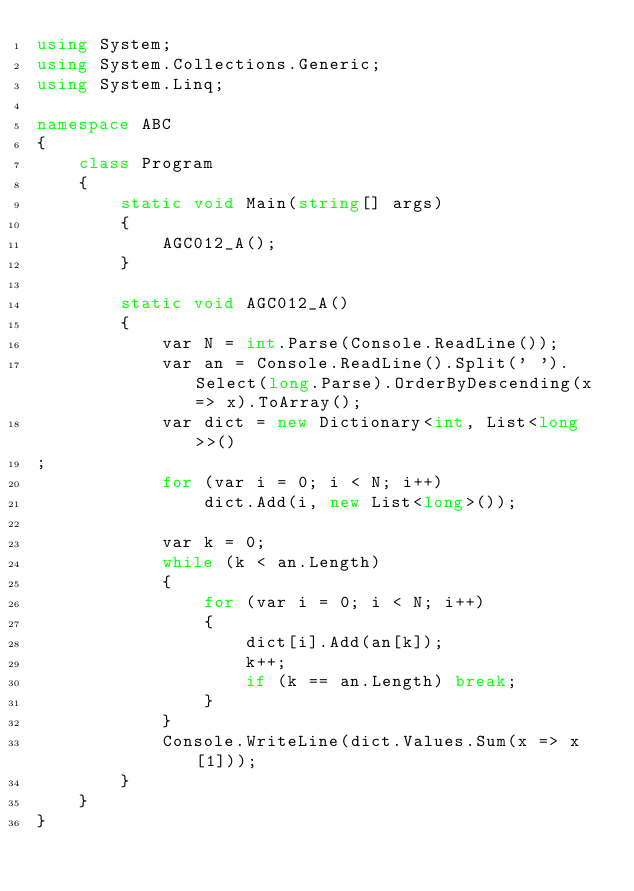<code> <loc_0><loc_0><loc_500><loc_500><_C#_>using System;
using System.Collections.Generic;
using System.Linq;

namespace ABC
{
    class Program
    {
        static void Main(string[] args)
        {
            AGC012_A();
        }

        static void AGC012_A()
        {
            var N = int.Parse(Console.ReadLine());
            var an = Console.ReadLine().Split(' ').Select(long.Parse).OrderByDescending(x => x).ToArray();
            var dict = new Dictionary<int, List<long>>()
;
            for (var i = 0; i < N; i++)
                dict.Add(i, new List<long>());

            var k = 0;
            while (k < an.Length)
            {
                for (var i = 0; i < N; i++)
                {
                    dict[i].Add(an[k]);
                    k++;
                    if (k == an.Length) break;
                }
            }
            Console.WriteLine(dict.Values.Sum(x => x[1]));
        }
    }
}</code> 